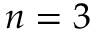Convert formula to latex. <formula><loc_0><loc_0><loc_500><loc_500>n = 3</formula> 